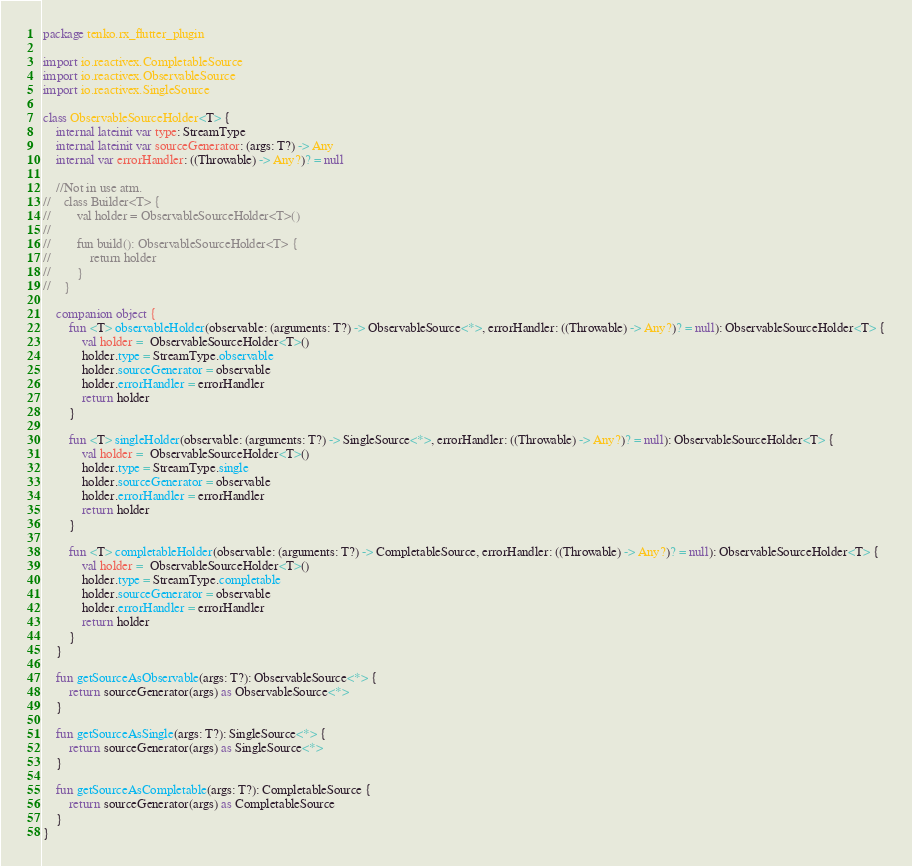Convert code to text. <code><loc_0><loc_0><loc_500><loc_500><_Kotlin_>package tenko.rx_flutter_plugin

import io.reactivex.CompletableSource
import io.reactivex.ObservableSource
import io.reactivex.SingleSource

class ObservableSourceHolder<T> {
    internal lateinit var type: StreamType
    internal lateinit var sourceGenerator: (args: T?) -> Any
    internal var errorHandler: ((Throwable) -> Any?)? = null

    //Not in use atm.
//    class Builder<T> {
//        val holder = ObservableSourceHolder<T>()
//
//        fun build(): ObservableSourceHolder<T> {
//            return holder
//        }
//    }

    companion object {
        fun <T> observableHolder(observable: (arguments: T?) -> ObservableSource<*>, errorHandler: ((Throwable) -> Any?)? = null): ObservableSourceHolder<T> {
            val holder =  ObservableSourceHolder<T>()
            holder.type = StreamType.observable
            holder.sourceGenerator = observable
            holder.errorHandler = errorHandler
            return holder
        }

        fun <T> singleHolder(observable: (arguments: T?) -> SingleSource<*>, errorHandler: ((Throwable) -> Any?)? = null): ObservableSourceHolder<T> {
            val holder =  ObservableSourceHolder<T>()
            holder.type = StreamType.single
            holder.sourceGenerator = observable
            holder.errorHandler = errorHandler
            return holder
        }

        fun <T> completableHolder(observable: (arguments: T?) -> CompletableSource, errorHandler: ((Throwable) -> Any?)? = null): ObservableSourceHolder<T> {
            val holder =  ObservableSourceHolder<T>()
            holder.type = StreamType.completable
            holder.sourceGenerator = observable
            holder.errorHandler = errorHandler
            return holder
        }
    }

    fun getSourceAsObservable(args: T?): ObservableSource<*> {
        return sourceGenerator(args) as ObservableSource<*>
    }

    fun getSourceAsSingle(args: T?): SingleSource<*> {
        return sourceGenerator(args) as SingleSource<*>
    }

    fun getSourceAsCompletable(args: T?): CompletableSource {
        return sourceGenerator(args) as CompletableSource
    }
}</code> 